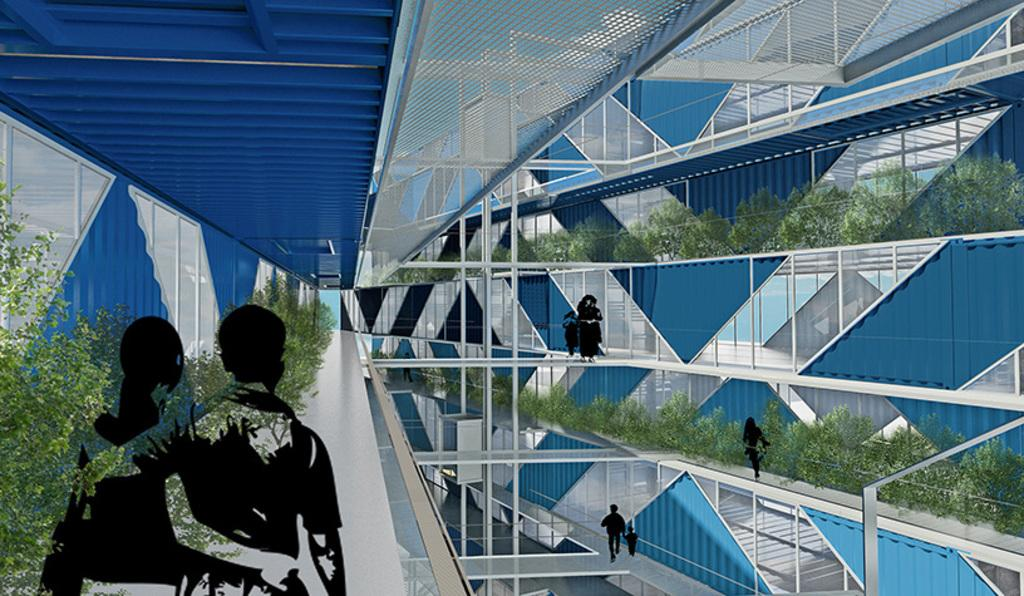What type of location is depicted in the image? The image shows an inside view of a building. Are there any living beings present in the image? Yes, there are people in the image. What can be found on the floor in the image? There are plants on the floor in the image. What is visible in the background of the image? There is a roof visible in the background of the image. What type of beef is being served in the image? There is no beef present in the image; it shows an inside view of a building with people and plants. Can you tell me the credit score of the person in the image? There is no information about credit scores in the image; it only shows an inside view of a building with people and plants. 